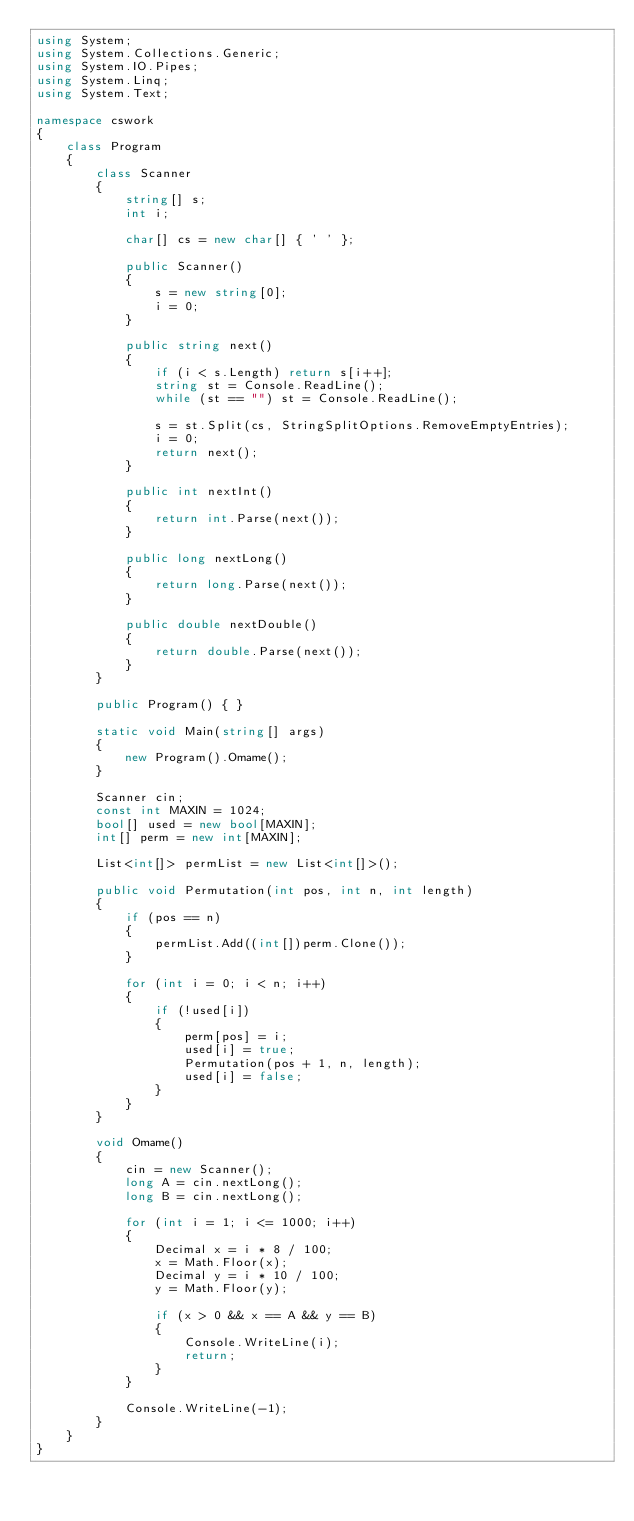Convert code to text. <code><loc_0><loc_0><loc_500><loc_500><_C#_>using System;
using System.Collections.Generic;
using System.IO.Pipes;
using System.Linq;
using System.Text;

namespace cswork
{
    class Program
    {
        class Scanner
        {
            string[] s;
            int i;

            char[] cs = new char[] { ' ' };

            public Scanner()
            {
                s = new string[0];
                i = 0;
            }

            public string next()
            {
                if (i < s.Length) return s[i++];
                string st = Console.ReadLine();
                while (st == "") st = Console.ReadLine();

                s = st.Split(cs, StringSplitOptions.RemoveEmptyEntries);
                i = 0;
                return next();
            }

            public int nextInt()
            {
                return int.Parse(next());
            }

            public long nextLong()
            {
                return long.Parse(next());
            }

            public double nextDouble()
            {
                return double.Parse(next());
            }
        }

        public Program() { }

        static void Main(string[] args)
        {
            new Program().Omame();
        }

        Scanner cin;
        const int MAXIN = 1024;
        bool[] used = new bool[MAXIN];
        int[] perm = new int[MAXIN];

        List<int[]> permList = new List<int[]>();

        public void Permutation(int pos, int n, int length)
        {
            if (pos == n)
            {
                permList.Add((int[])perm.Clone());
            }

            for (int i = 0; i < n; i++)
            {
                if (!used[i])
                {
                    perm[pos] = i;
                    used[i] = true;
                    Permutation(pos + 1, n, length);
                    used[i] = false;
                }
            }
        }

        void Omame()
        {
            cin = new Scanner();
            long A = cin.nextLong();
            long B = cin.nextLong();

            for (int i = 1; i <= 1000; i++)
            {
                Decimal x = i * 8 / 100;
                x = Math.Floor(x);
                Decimal y = i * 10 / 100;
                y = Math.Floor(y);

                if (x > 0 && x == A && y == B)
                {
                    Console.WriteLine(i);
                    return;
                }
            }

            Console.WriteLine(-1);
        }
    }
}
</code> 